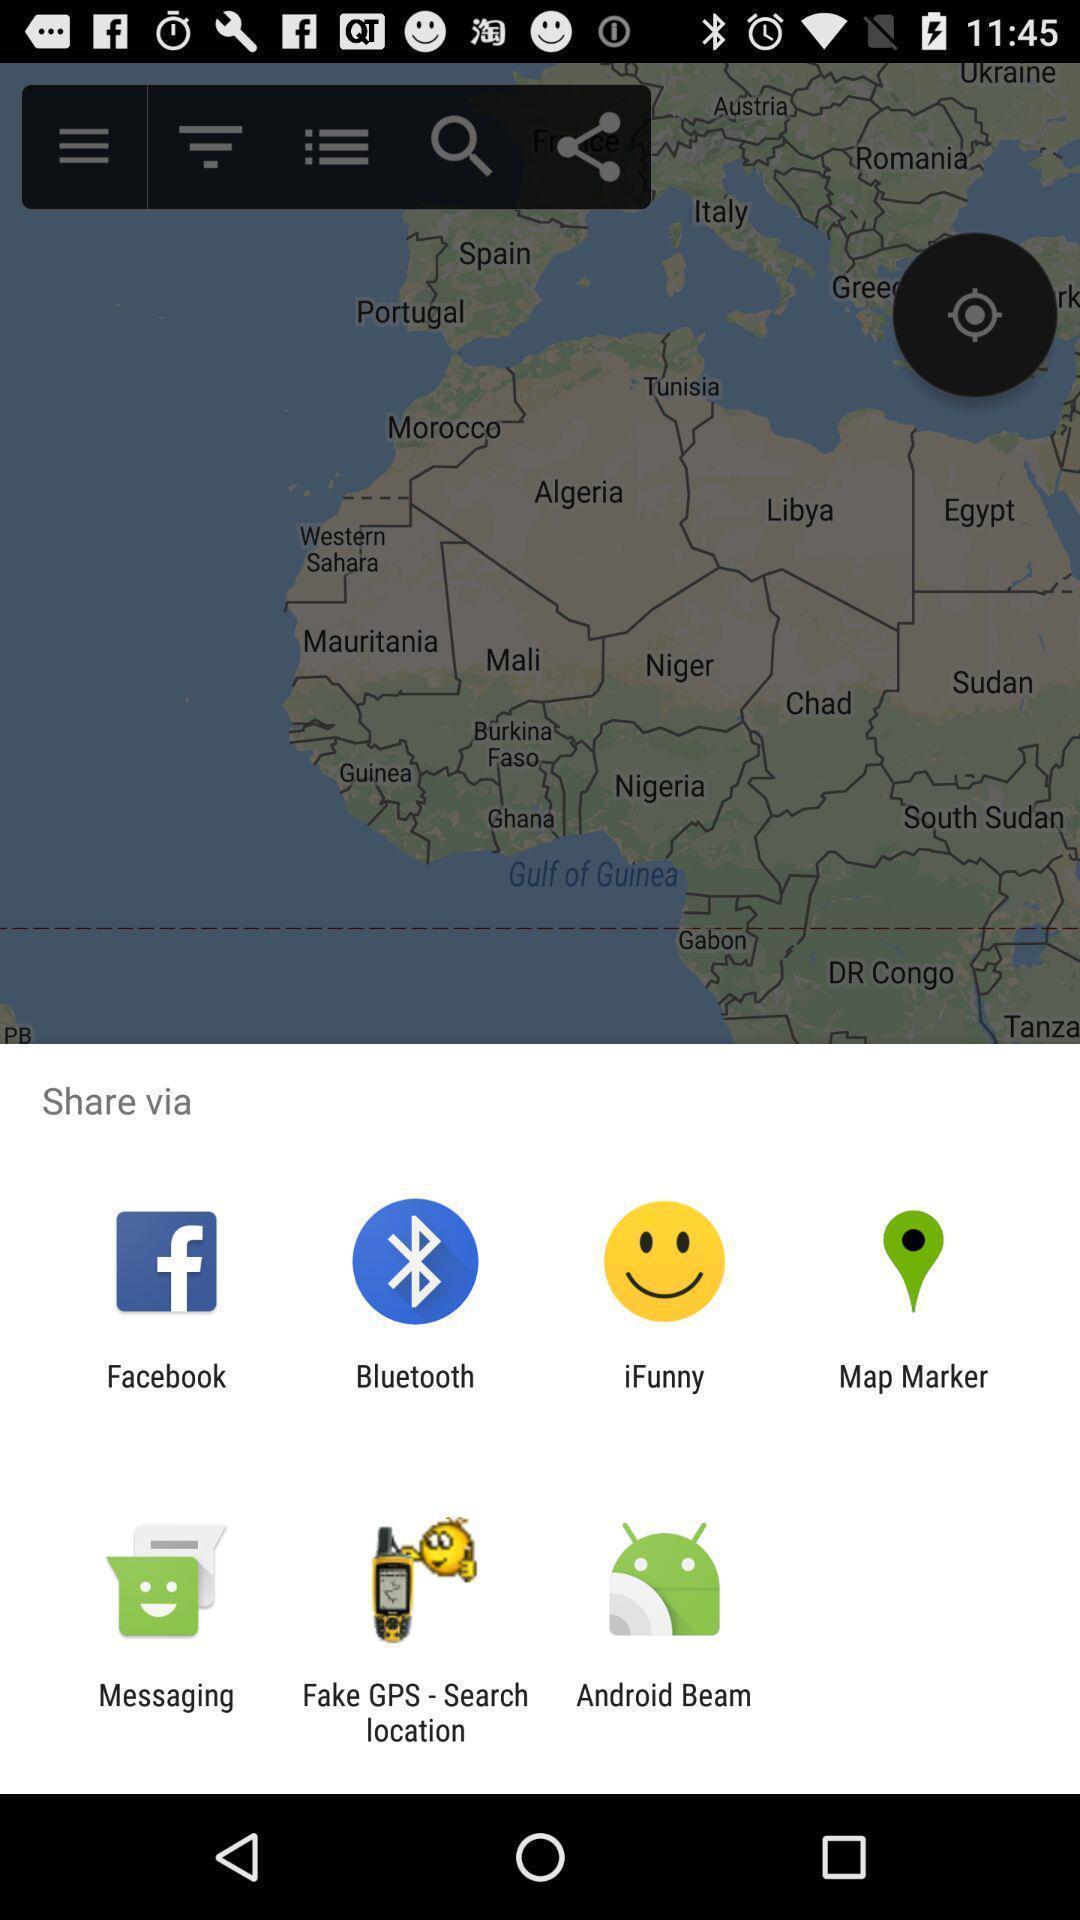What can you discern from this picture? Push up displaying multiple apps to share. 